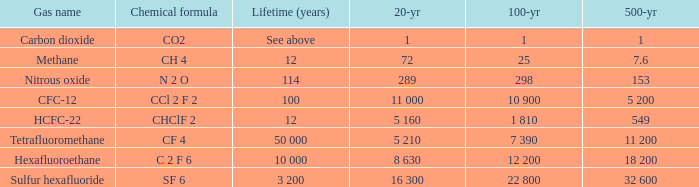What is the 100 year when 500 year is 153? 298.0. 